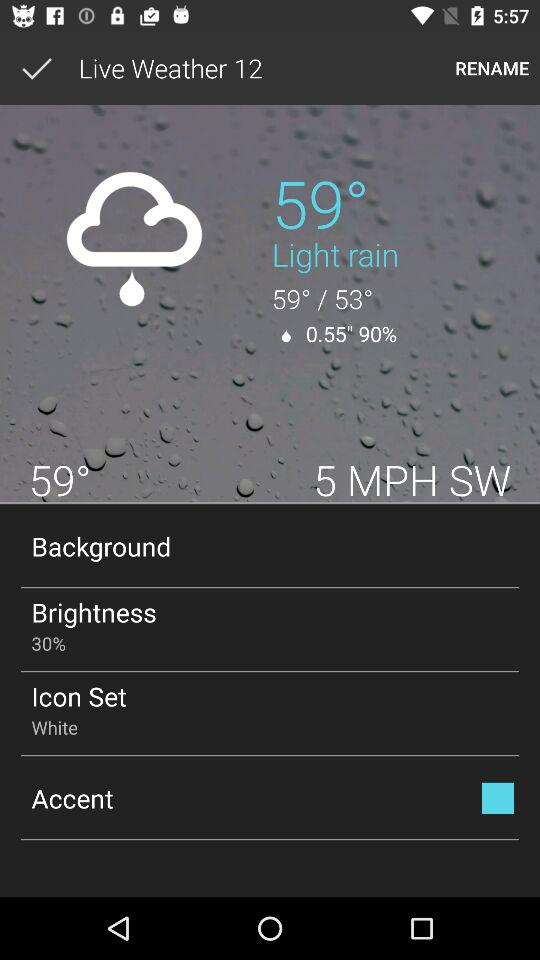How much is the brightness? The brightness is 30%. 